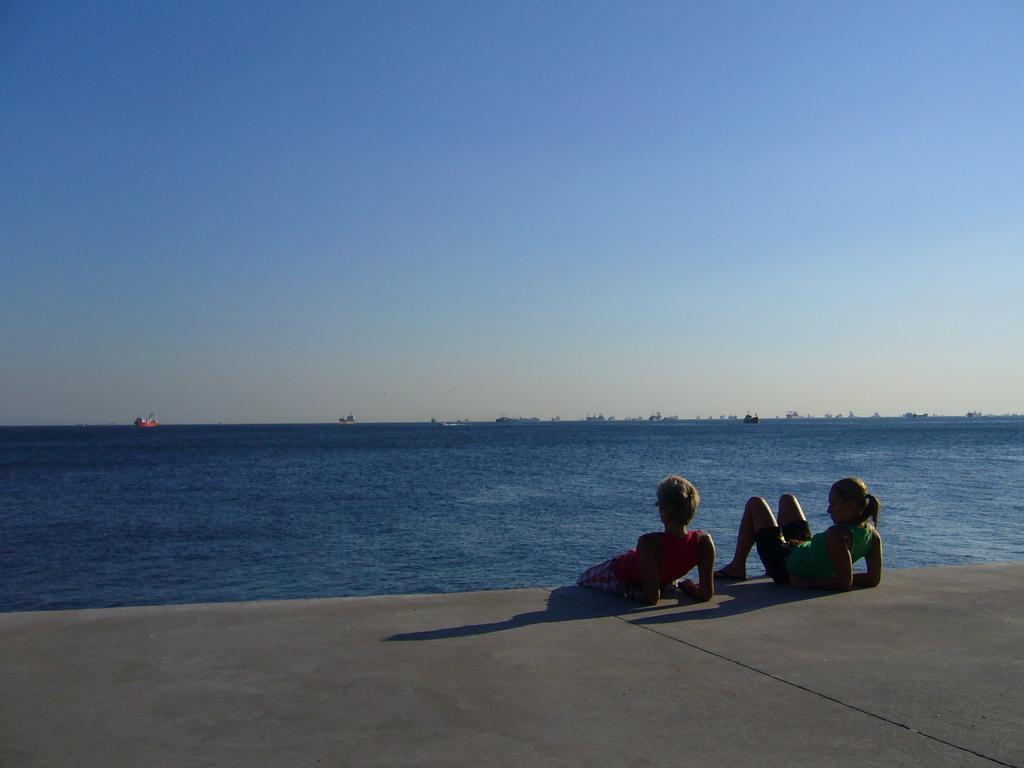Can you describe this image briefly? In this picture there are two women who are lying on the ground. In the background I can see many boats on the river. At the top I can see the sky. 